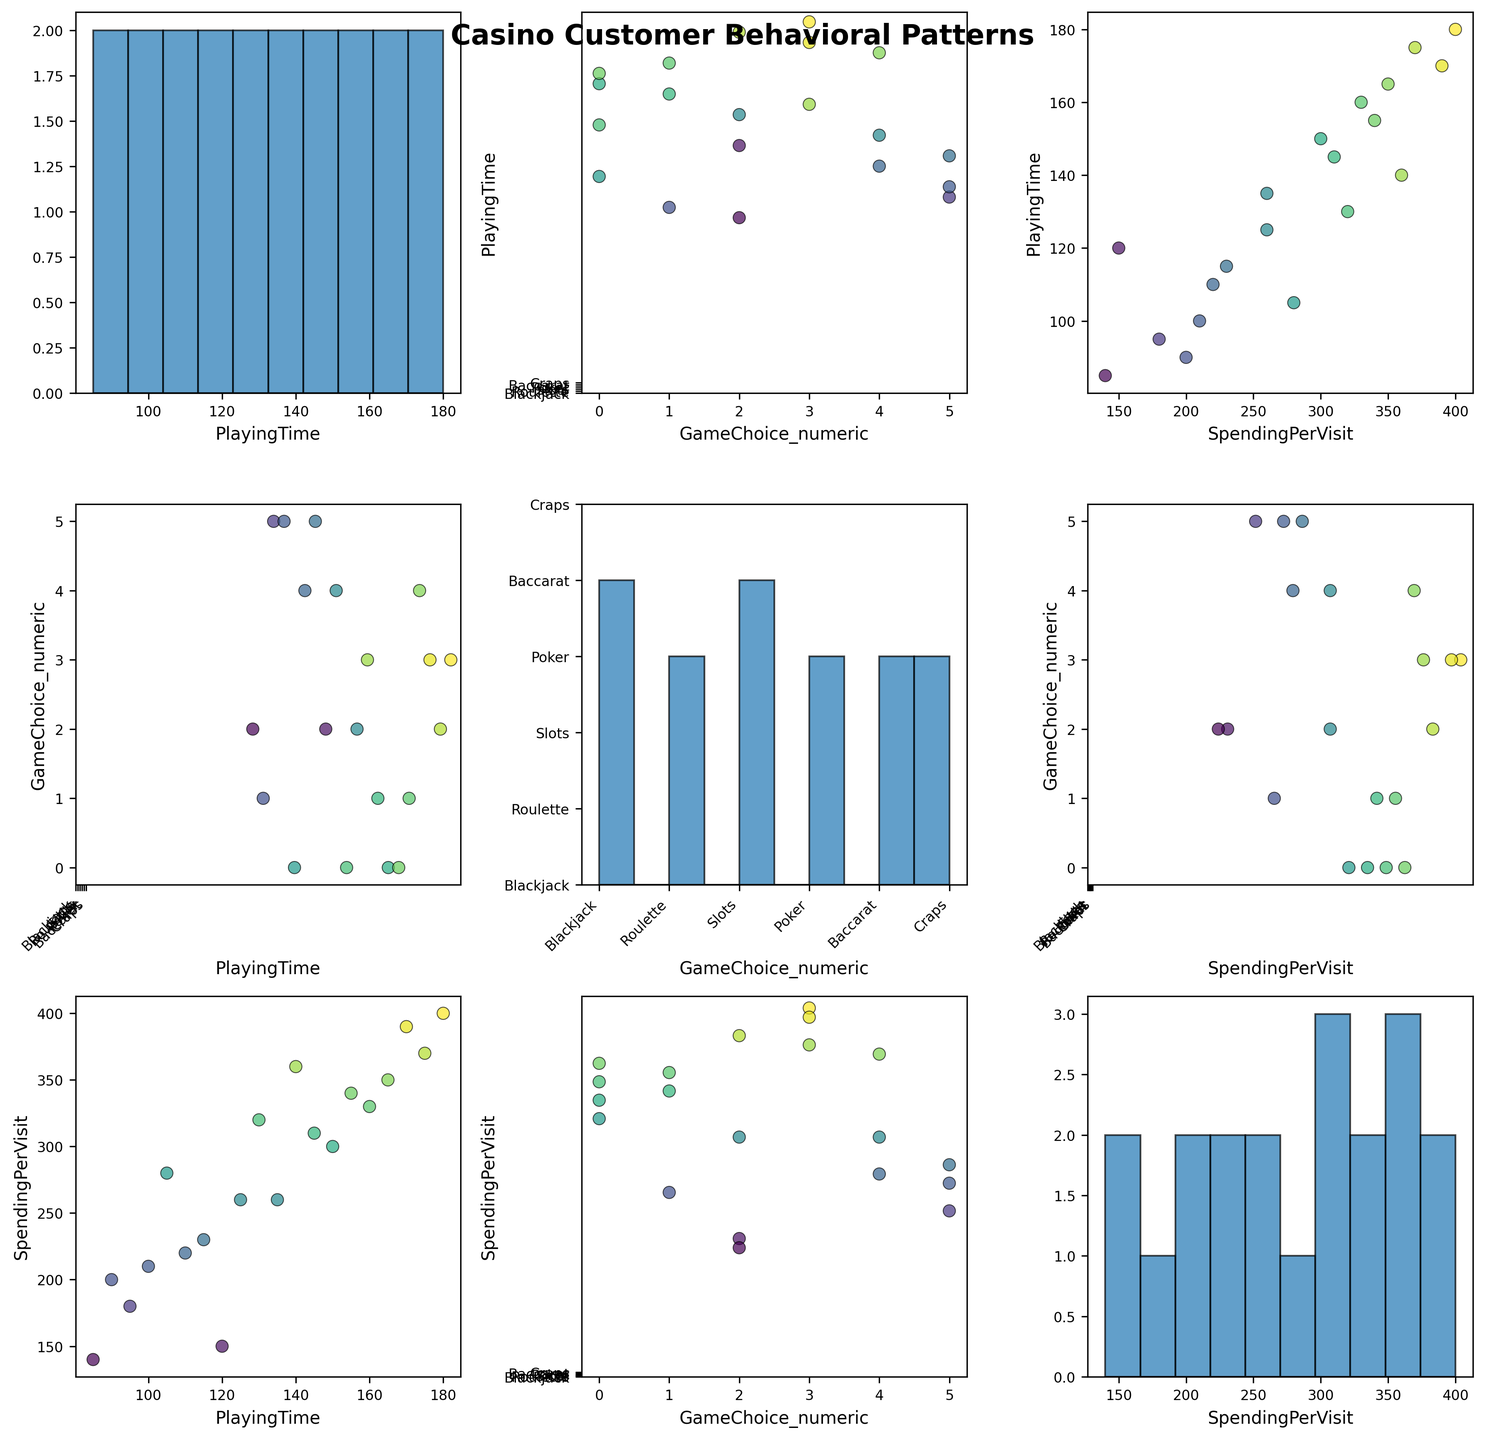What is the title of the figure? The title of the figure is usually displayed at the top of the plot. According to the code, it is "Casino Customer Behavioral Patterns".
Answer: Casino Customer Behavioral Patterns How is the playing time displayed in relation to spending per visit? The playing time data is displayed on the vertical axes in scatter plots within the matrix, and spending per visit is displayed on the horizontal axes where the plots intersect. We can observe how the points distribute across these dimensions to understand their relationship.
Answer: Scatter plot of playing time vs spending per visit Which games do customers spend the most time playing on average based on the histograms? By looking at the histogram along the diagonal for the "GameChoice" axis, we can see the distribution of playing time for each game. The game with the highest concentration of longer playing times can be identified visually.
Answer: Poker and Blackjack Is there a noticeable correlation between game choice and spending per visit? Observing the scatter plots where "GameChoice" is on one axis and "SpendingPerVisit" is on the other, we can look for any clear patterns or trends where game choice appears to affect the spending per visit.
Answer: Yes, some correlations are noticeable Which combination of variables shows the most spread of data points? By comparing different scatter plots, we can identify which combination has the largest spread of points. This suggests greater variability in customer behavior for those combinations of variables.
Answer: Playing time and spending per visit Do any games have a higher range of spending per visit? By looking at the scatter plots with "GameChoice" along one axis and "SpendingPerVisit" along the other, we can see which game has a wider spread of spending values.
Answer: Poker and Roulette Is there a relationship between increased playing time and higher spending per visit? By examining the scatter plots of playing time versus spending per visit, we can see if there is a tendency for points to ascend diagonally, suggesting that higher playing times correlate with higher spending.
Answer: Yes, there is a positive relationship What is the color gradient used in the scatter plots indicating? The color gradient (viridis) typically represents another dimension of data. In this plot, it indicates the amount of spending per visit. Points with different colors represent different spending amounts.
Answer: Spending per visit Which game shows the highest average spending per visit based on scatter plot trends? By observing the scatter plots with "SpendingPerVisit" on one axis and "GameChoice" on the other, we can identify which game has points predominantly at higher spending values.
Answer: Poker 